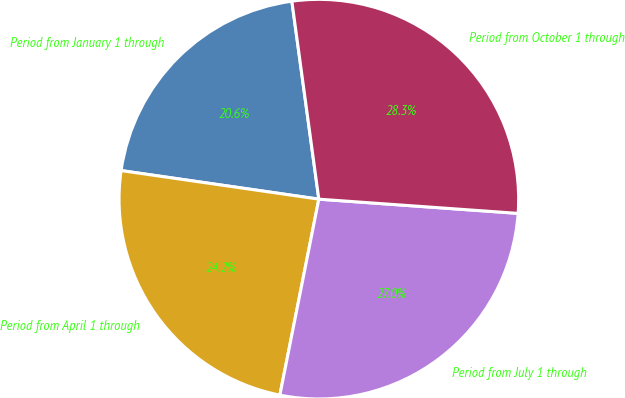<chart> <loc_0><loc_0><loc_500><loc_500><pie_chart><fcel>Period from January 1 through<fcel>Period from April 1 through<fcel>Period from July 1 through<fcel>Period from October 1 through<nl><fcel>20.56%<fcel>24.16%<fcel>26.99%<fcel>28.29%<nl></chart> 